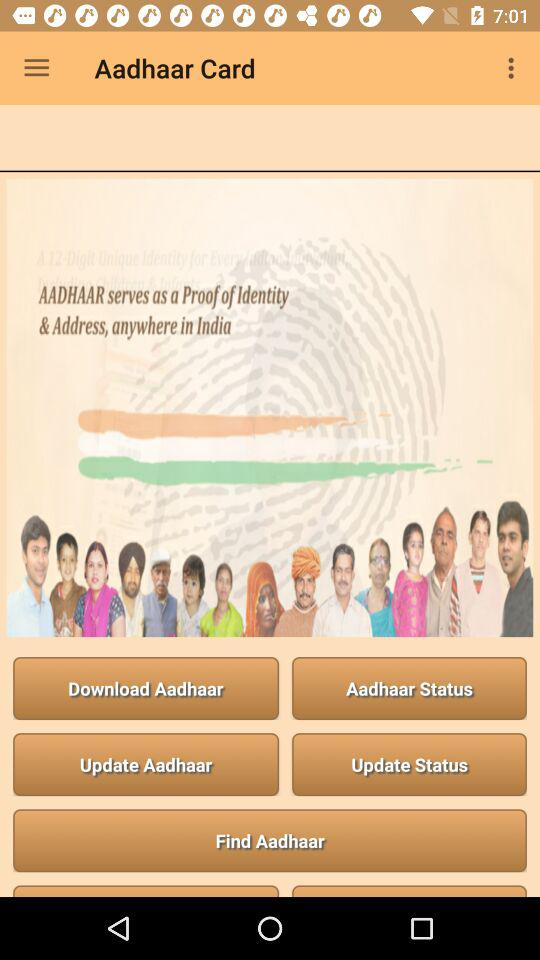What purpose does the "AADHAAR" serve? The "AADHAAR" serves as a proof of identity and address, anywhere in India. 